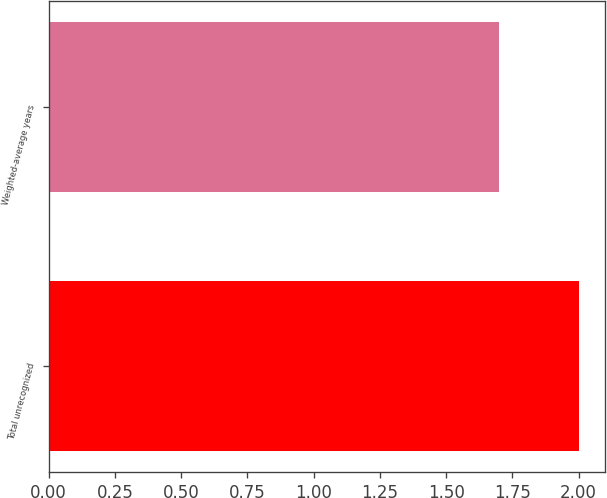Convert chart to OTSL. <chart><loc_0><loc_0><loc_500><loc_500><bar_chart><fcel>Total unrecognized<fcel>Weighted-average years<nl><fcel>2<fcel>1.7<nl></chart> 